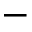Convert formula to latex. <formula><loc_0><loc_0><loc_500><loc_500>-</formula> 